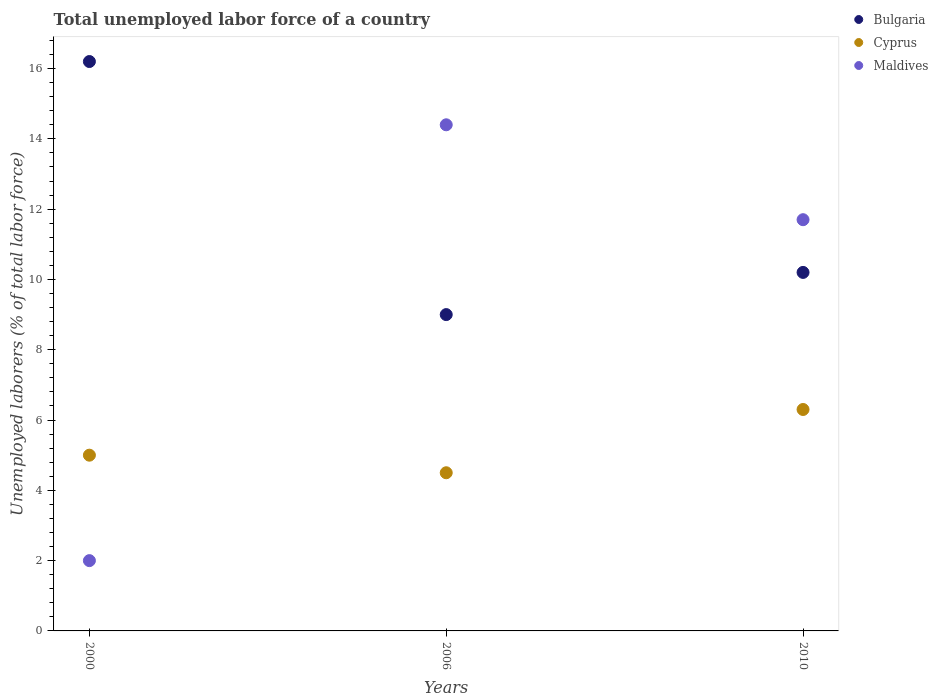Is the number of dotlines equal to the number of legend labels?
Offer a very short reply. Yes. What is the total unemployed labor force in Bulgaria in 2000?
Offer a very short reply. 16.2. Across all years, what is the maximum total unemployed labor force in Maldives?
Provide a succinct answer. 14.4. What is the total total unemployed labor force in Bulgaria in the graph?
Offer a very short reply. 35.4. What is the difference between the total unemployed labor force in Bulgaria in 2000 and that in 2006?
Make the answer very short. 7.2. What is the average total unemployed labor force in Bulgaria per year?
Provide a succinct answer. 11.8. In the year 2010, what is the difference between the total unemployed labor force in Bulgaria and total unemployed labor force in Maldives?
Provide a short and direct response. -1.5. What is the ratio of the total unemployed labor force in Cyprus in 2000 to that in 2006?
Your answer should be very brief. 1.11. Is the difference between the total unemployed labor force in Bulgaria in 2000 and 2006 greater than the difference between the total unemployed labor force in Maldives in 2000 and 2006?
Provide a succinct answer. Yes. What is the difference between the highest and the second highest total unemployed labor force in Maldives?
Provide a short and direct response. 2.7. What is the difference between the highest and the lowest total unemployed labor force in Cyprus?
Ensure brevity in your answer.  1.8. In how many years, is the total unemployed labor force in Maldives greater than the average total unemployed labor force in Maldives taken over all years?
Your response must be concise. 2. Is the sum of the total unemployed labor force in Maldives in 2000 and 2006 greater than the maximum total unemployed labor force in Cyprus across all years?
Your response must be concise. Yes. Is it the case that in every year, the sum of the total unemployed labor force in Maldives and total unemployed labor force in Cyprus  is greater than the total unemployed labor force in Bulgaria?
Your answer should be very brief. No. Does the total unemployed labor force in Cyprus monotonically increase over the years?
Offer a very short reply. No. Is the total unemployed labor force in Maldives strictly less than the total unemployed labor force in Cyprus over the years?
Keep it short and to the point. No. How many dotlines are there?
Your answer should be compact. 3. What is the difference between two consecutive major ticks on the Y-axis?
Provide a short and direct response. 2. Does the graph contain any zero values?
Ensure brevity in your answer.  No. Where does the legend appear in the graph?
Ensure brevity in your answer.  Top right. How many legend labels are there?
Keep it short and to the point. 3. What is the title of the graph?
Make the answer very short. Total unemployed labor force of a country. Does "Germany" appear as one of the legend labels in the graph?
Your answer should be compact. No. What is the label or title of the Y-axis?
Keep it short and to the point. Unemployed laborers (% of total labor force). What is the Unemployed laborers (% of total labor force) of Bulgaria in 2000?
Give a very brief answer. 16.2. What is the Unemployed laborers (% of total labor force) in Maldives in 2006?
Give a very brief answer. 14.4. What is the Unemployed laborers (% of total labor force) in Bulgaria in 2010?
Provide a succinct answer. 10.2. What is the Unemployed laborers (% of total labor force) of Cyprus in 2010?
Provide a succinct answer. 6.3. What is the Unemployed laborers (% of total labor force) of Maldives in 2010?
Your answer should be very brief. 11.7. Across all years, what is the maximum Unemployed laborers (% of total labor force) in Bulgaria?
Keep it short and to the point. 16.2. Across all years, what is the maximum Unemployed laborers (% of total labor force) in Cyprus?
Provide a succinct answer. 6.3. Across all years, what is the maximum Unemployed laborers (% of total labor force) in Maldives?
Provide a succinct answer. 14.4. Across all years, what is the minimum Unemployed laborers (% of total labor force) in Bulgaria?
Your answer should be very brief. 9. Across all years, what is the minimum Unemployed laborers (% of total labor force) in Cyprus?
Your answer should be very brief. 4.5. Across all years, what is the minimum Unemployed laborers (% of total labor force) in Maldives?
Offer a terse response. 2. What is the total Unemployed laborers (% of total labor force) of Bulgaria in the graph?
Give a very brief answer. 35.4. What is the total Unemployed laborers (% of total labor force) in Cyprus in the graph?
Your answer should be compact. 15.8. What is the total Unemployed laborers (% of total labor force) in Maldives in the graph?
Provide a succinct answer. 28.1. What is the difference between the Unemployed laborers (% of total labor force) in Bulgaria in 2000 and that in 2006?
Give a very brief answer. 7.2. What is the difference between the Unemployed laborers (% of total labor force) of Cyprus in 2000 and that in 2006?
Your answer should be very brief. 0.5. What is the difference between the Unemployed laborers (% of total labor force) of Bulgaria in 2000 and that in 2010?
Give a very brief answer. 6. What is the difference between the Unemployed laborers (% of total labor force) of Cyprus in 2000 and that in 2010?
Your answer should be very brief. -1.3. What is the difference between the Unemployed laborers (% of total labor force) of Maldives in 2000 and that in 2010?
Your answer should be very brief. -9.7. What is the difference between the Unemployed laborers (% of total labor force) of Bulgaria in 2000 and the Unemployed laborers (% of total labor force) of Cyprus in 2006?
Provide a short and direct response. 11.7. What is the difference between the Unemployed laborers (% of total labor force) in Cyprus in 2000 and the Unemployed laborers (% of total labor force) in Maldives in 2006?
Your answer should be very brief. -9.4. What is the difference between the Unemployed laborers (% of total labor force) in Bulgaria in 2000 and the Unemployed laborers (% of total labor force) in Cyprus in 2010?
Make the answer very short. 9.9. What is the difference between the Unemployed laborers (% of total labor force) in Bulgaria in 2000 and the Unemployed laborers (% of total labor force) in Maldives in 2010?
Make the answer very short. 4.5. What is the average Unemployed laborers (% of total labor force) in Bulgaria per year?
Ensure brevity in your answer.  11.8. What is the average Unemployed laborers (% of total labor force) in Cyprus per year?
Offer a terse response. 5.27. What is the average Unemployed laborers (% of total labor force) of Maldives per year?
Provide a succinct answer. 9.37. In the year 2000, what is the difference between the Unemployed laborers (% of total labor force) of Bulgaria and Unemployed laborers (% of total labor force) of Maldives?
Offer a very short reply. 14.2. In the year 2000, what is the difference between the Unemployed laborers (% of total labor force) of Cyprus and Unemployed laborers (% of total labor force) of Maldives?
Provide a succinct answer. 3. In the year 2006, what is the difference between the Unemployed laborers (% of total labor force) in Bulgaria and Unemployed laborers (% of total labor force) in Maldives?
Your answer should be very brief. -5.4. In the year 2006, what is the difference between the Unemployed laborers (% of total labor force) of Cyprus and Unemployed laborers (% of total labor force) of Maldives?
Your response must be concise. -9.9. In the year 2010, what is the difference between the Unemployed laborers (% of total labor force) of Bulgaria and Unemployed laborers (% of total labor force) of Cyprus?
Your answer should be compact. 3.9. In the year 2010, what is the difference between the Unemployed laborers (% of total labor force) of Cyprus and Unemployed laborers (% of total labor force) of Maldives?
Ensure brevity in your answer.  -5.4. What is the ratio of the Unemployed laborers (% of total labor force) of Cyprus in 2000 to that in 2006?
Your answer should be very brief. 1.11. What is the ratio of the Unemployed laborers (% of total labor force) of Maldives in 2000 to that in 2006?
Your answer should be compact. 0.14. What is the ratio of the Unemployed laborers (% of total labor force) of Bulgaria in 2000 to that in 2010?
Offer a very short reply. 1.59. What is the ratio of the Unemployed laborers (% of total labor force) of Cyprus in 2000 to that in 2010?
Your response must be concise. 0.79. What is the ratio of the Unemployed laborers (% of total labor force) in Maldives in 2000 to that in 2010?
Ensure brevity in your answer.  0.17. What is the ratio of the Unemployed laborers (% of total labor force) of Bulgaria in 2006 to that in 2010?
Provide a succinct answer. 0.88. What is the ratio of the Unemployed laborers (% of total labor force) of Maldives in 2006 to that in 2010?
Provide a succinct answer. 1.23. What is the difference between the highest and the second highest Unemployed laborers (% of total labor force) of Bulgaria?
Give a very brief answer. 6. What is the difference between the highest and the second highest Unemployed laborers (% of total labor force) of Maldives?
Offer a very short reply. 2.7. What is the difference between the highest and the lowest Unemployed laborers (% of total labor force) of Bulgaria?
Offer a very short reply. 7.2. What is the difference between the highest and the lowest Unemployed laborers (% of total labor force) of Cyprus?
Keep it short and to the point. 1.8. What is the difference between the highest and the lowest Unemployed laborers (% of total labor force) of Maldives?
Provide a short and direct response. 12.4. 